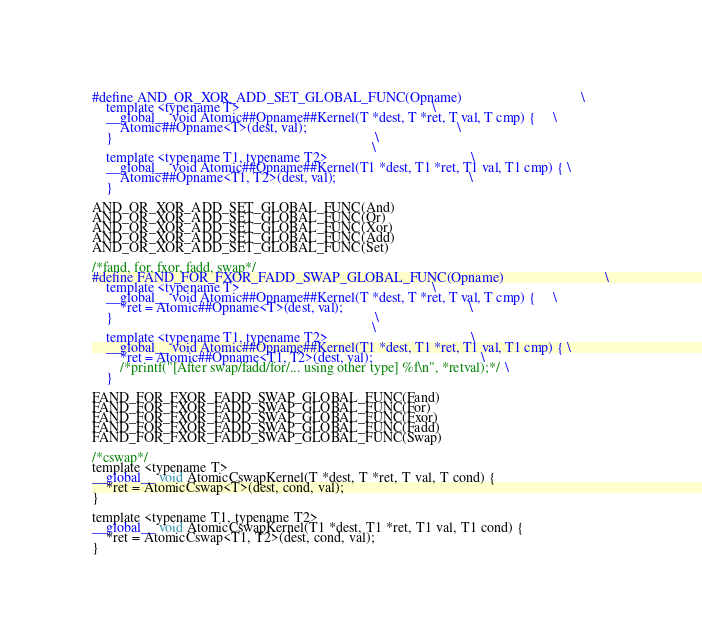<code> <loc_0><loc_0><loc_500><loc_500><_Cuda_>#define AND_OR_XOR_ADD_SET_GLOBAL_FUNC(Opname)                                  \
    template <typename T>                                                       \
    __global__ void Atomic##Opname##Kernel(T *dest, T *ret, T val, T cmp) {     \
        Atomic##Opname<T>(dest, val);                                           \
    }                                                                           \
                                                                                \
    template <typename T1, typename T2>                                         \
    __global__ void Atomic##Opname##Kernel(T1 *dest, T1 *ret, T1 val, T1 cmp) { \
        Atomic##Opname<T1, T2>(dest, val);                                      \
    }

AND_OR_XOR_ADD_SET_GLOBAL_FUNC(And)
AND_OR_XOR_ADD_SET_GLOBAL_FUNC(Or)
AND_OR_XOR_ADD_SET_GLOBAL_FUNC(Xor)
AND_OR_XOR_ADD_SET_GLOBAL_FUNC(Add)
AND_OR_XOR_ADD_SET_GLOBAL_FUNC(Set)

/*fand, for, fxor, fadd, swap*/
#define FAND_FOR_FXOR_FADD_SWAP_GLOBAL_FUNC(Opname)                             \
    template <typename T>                                                       \
    __global__ void Atomic##Opname##Kernel(T *dest, T *ret, T val, T cmp) {     \
        *ret = Atomic##Opname<T>(dest, val);                                    \
    }                                                                           \
                                                                                \
    template <typename T1, typename T2>                                         \
    __global__ void Atomic##Opname##Kernel(T1 *dest, T1 *ret, T1 val, T1 cmp) { \
        *ret = Atomic##Opname<T1, T2>(dest, val);                               \
        /*printf("[After swap/fadd/for/... using other type] %f\n", *retval);*/ \
    }

FAND_FOR_FXOR_FADD_SWAP_GLOBAL_FUNC(Fand)
FAND_FOR_FXOR_FADD_SWAP_GLOBAL_FUNC(For)
FAND_FOR_FXOR_FADD_SWAP_GLOBAL_FUNC(Fxor)
FAND_FOR_FXOR_FADD_SWAP_GLOBAL_FUNC(Fadd)
FAND_FOR_FXOR_FADD_SWAP_GLOBAL_FUNC(Swap)

/*cswap*/
template <typename T>
__global__ void AtomicCswapKernel(T *dest, T *ret, T val, T cond) {
    *ret = AtomicCswap<T>(dest, cond, val);
}

template <typename T1, typename T2>
__global__ void AtomicCswapKernel(T1 *dest, T1 *ret, T1 val, T1 cond) {
    *ret = AtomicCswap<T1, T2>(dest, cond, val);
}
</code> 